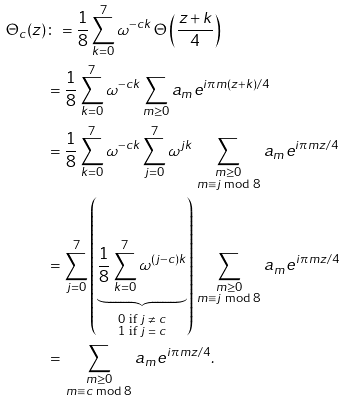Convert formula to latex. <formula><loc_0><loc_0><loc_500><loc_500>\Theta _ { c } ( z ) & \colon = \frac { 1 } { 8 } \sum _ { k = 0 } ^ { 7 } \omega ^ { - c k } \, \Theta \left ( \frac { z + k } { 4 } \right ) \\ & = \frac { 1 } { 8 } \sum _ { k = 0 } ^ { 7 } \omega ^ { - c k } \sum _ { m \geq 0 } a _ { m } e ^ { i \pi m ( z + k ) / 4 } \\ & = \frac { 1 } { 8 } \sum _ { k = 0 } ^ { 7 } \omega ^ { - c k } \sum _ { j = 0 } ^ { 7 } \omega ^ { j k } \sum _ { \, \substack { m \geq 0 \\ m \equiv j \bmod 8 } \, } a _ { m } e ^ { i \pi m z / 4 } \\ & = \sum _ { j = 0 } ^ { 7 } \left ( \underbrace { \frac { 1 } { 8 } \sum _ { k = 0 } ^ { 7 } \omega ^ { ( j - c ) k } } _ { \substack { \text {$0$ if $j\ne c$} \\ \text {$1$ if $j=c$} } } \right ) \sum _ { \, \substack { m \geq 0 \\ m \equiv j \bmod 8 } \, } a _ { m } e ^ { i \pi m z / 4 } \\ & = \sum _ { \, \substack { m \geq 0 \\ m \equiv c \bmod 8 } \, } a _ { m } e ^ { i \pi m z / 4 } .</formula> 